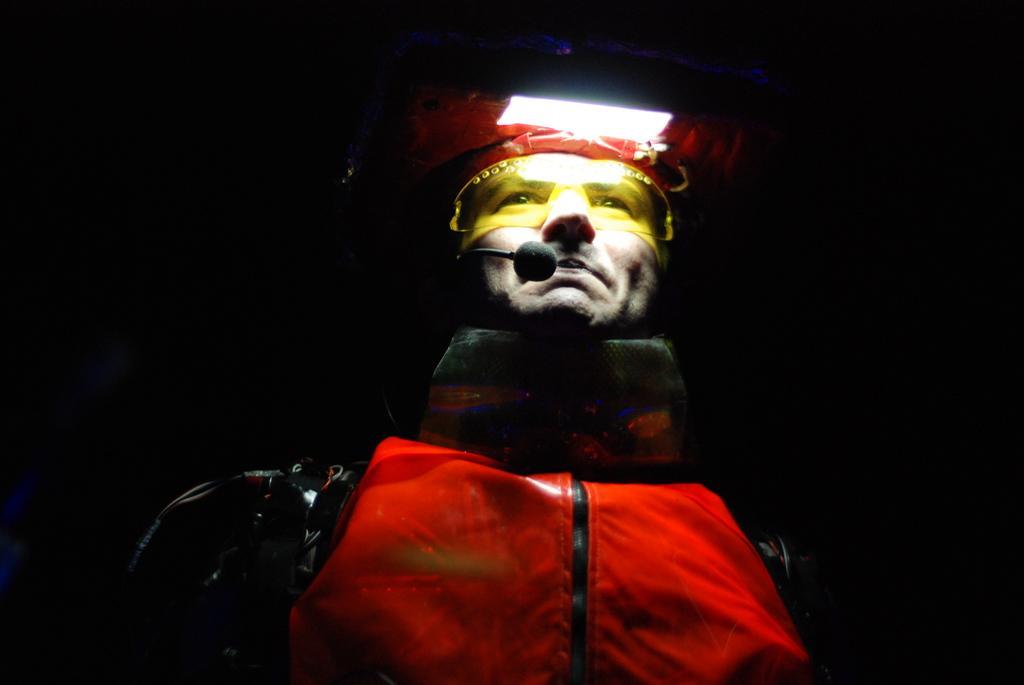Can you describe this image briefly? In the image there is a man dressed up in a variety costume and he is wearing yellow goggles and there is a mic in front of his mouth and a light is attached to his head and the background of the man is black. 